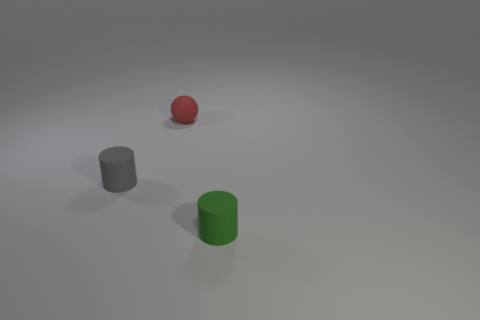Add 1 tiny gray cylinders. How many objects exist? 4 Subtract all spheres. How many objects are left? 2 Add 1 green rubber cylinders. How many green rubber cylinders are left? 2 Add 2 small gray rubber cylinders. How many small gray rubber cylinders exist? 3 Subtract 0 cyan balls. How many objects are left? 3 Subtract all brown cylinders. Subtract all red spheres. How many cylinders are left? 2 Subtract all red rubber things. Subtract all big cyan things. How many objects are left? 2 